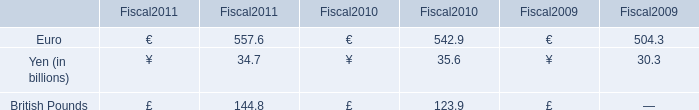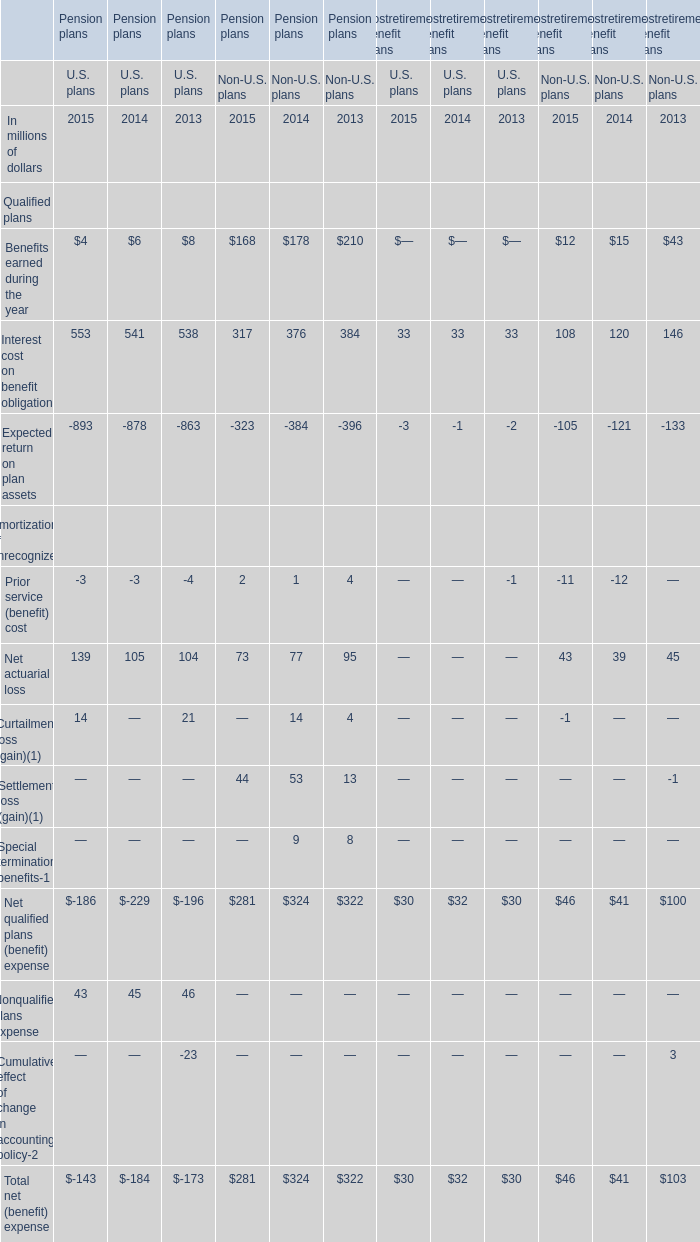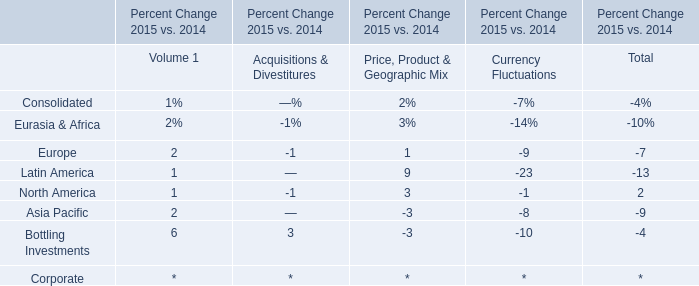Does the average value of Interest cost on benefit obligation in U.S. plans greater than that in Non-U.S. plans? 
Answer: yes. 